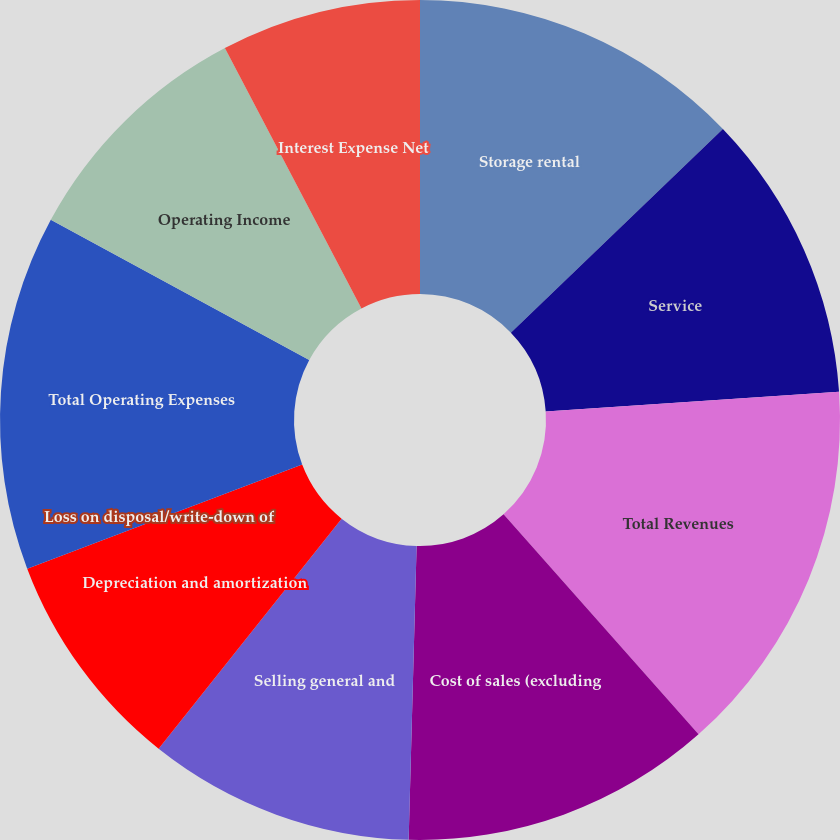<chart> <loc_0><loc_0><loc_500><loc_500><pie_chart><fcel>Storage rental<fcel>Service<fcel>Total Revenues<fcel>Cost of sales (excluding<fcel>Selling general and<fcel>Depreciation and amortization<fcel>Loss on disposal/write-down of<fcel>Total Operating Expenses<fcel>Operating Income<fcel>Interest Expense Net<nl><fcel>12.82%<fcel>11.11%<fcel>14.53%<fcel>11.97%<fcel>10.26%<fcel>8.55%<fcel>0.0%<fcel>13.67%<fcel>9.4%<fcel>7.69%<nl></chart> 